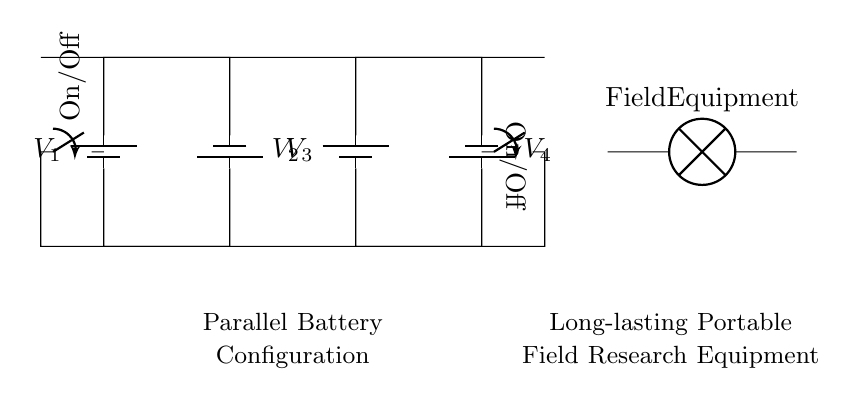What type of batteries are used in this configuration? The diagram specifies that the circuit uses batteries labeled as V1, V2, V3, and V4, indicating standard batteries in a parallel configuration.
Answer: Batteries What is the function of the switches in this circuit? The switches are used to control the flow of current to the field equipment. If the switch is open, the equipment will not receive power, while a closed switch allows current to flow.
Answer: On/Off What is the total voltage output of this parallel battery configuration? In a parallel configuration, the voltage remains the same as that of one individual battery; thus, the total voltage output is equal to each battery's voltage (for example, 1.5V if that is the assumed value).
Answer: Same as one battery How many batteries are present in total? The diagram shows a total of four batteries labeled as V1, V2, V3, and V4, indicating there are four batteries connected in parallel.
Answer: Four What type of load is connected to the output? The output of the configuration is connected to a lamp labeled "Field Equipment," indicating that the load is an electric lamp used for the research equipment.
Answer: Lamp Why is a parallel configuration chosen for battery use in field research? A parallel configuration allows for increased total capacity (current) while maintaining the same voltage, providing longer usage time for portable equipment in the field.
Answer: Longer-lasting 